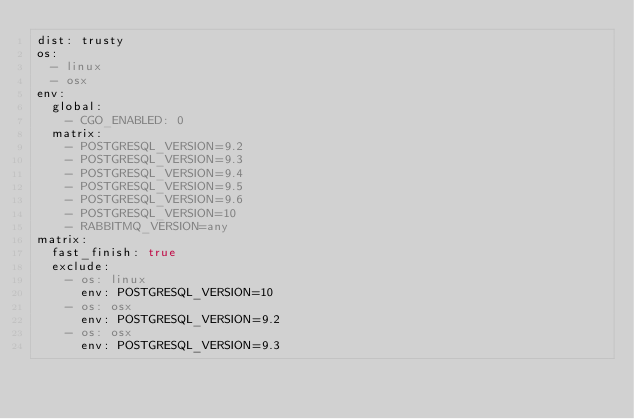<code> <loc_0><loc_0><loc_500><loc_500><_YAML_>dist: trusty
os:
  - linux
  - osx
env:
  global:
    - CGO_ENABLED: 0
  matrix:
    - POSTGRESQL_VERSION=9.2
    - POSTGRESQL_VERSION=9.3
    - POSTGRESQL_VERSION=9.4
    - POSTGRESQL_VERSION=9.5
    - POSTGRESQL_VERSION=9.6
    - POSTGRESQL_VERSION=10
    - RABBITMQ_VERSION=any
matrix:
  fast_finish: true
  exclude:
    - os: linux
      env: POSTGRESQL_VERSION=10
    - os: osx
      env: POSTGRESQL_VERSION=9.2
    - os: osx
      env: POSTGRESQL_VERSION=9.3
</code> 